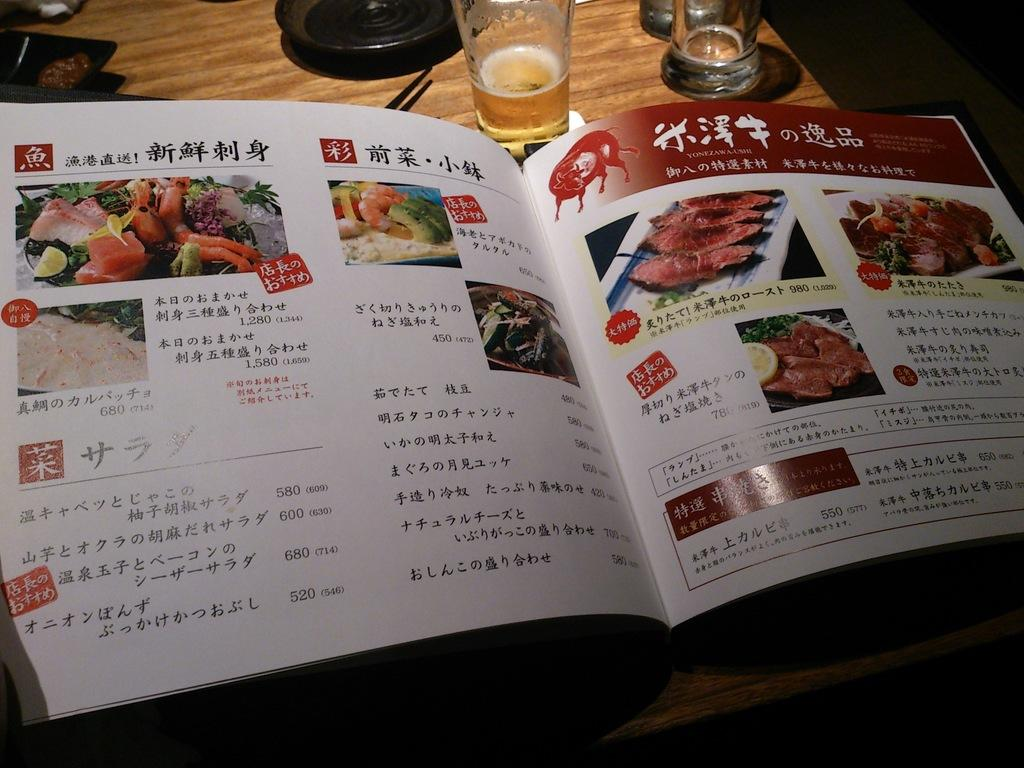What is the main object in the center of the image? There is a table in the center of the image. What is placed on the table? There is a book and a glass on the table. Are there any other objects on the table? Yes, there are other objects on the table. What type of nut is being used to open the hydrant in the image? There is no nut or hydrant present in the image; it only features a table with a book and a glass, along with other unspecified objects. 